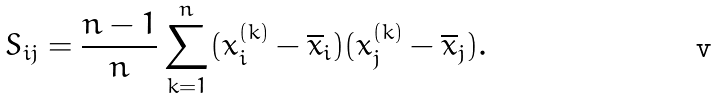Convert formula to latex. <formula><loc_0><loc_0><loc_500><loc_500>S _ { i j } = \frac { n - 1 } { n } \sum _ { k = 1 } ^ { n } ( x ^ { ( k ) } _ { i } - \overline { x } _ { i } ) ( x ^ { ( k ) } _ { j } - \overline { x } _ { j } ) .</formula> 